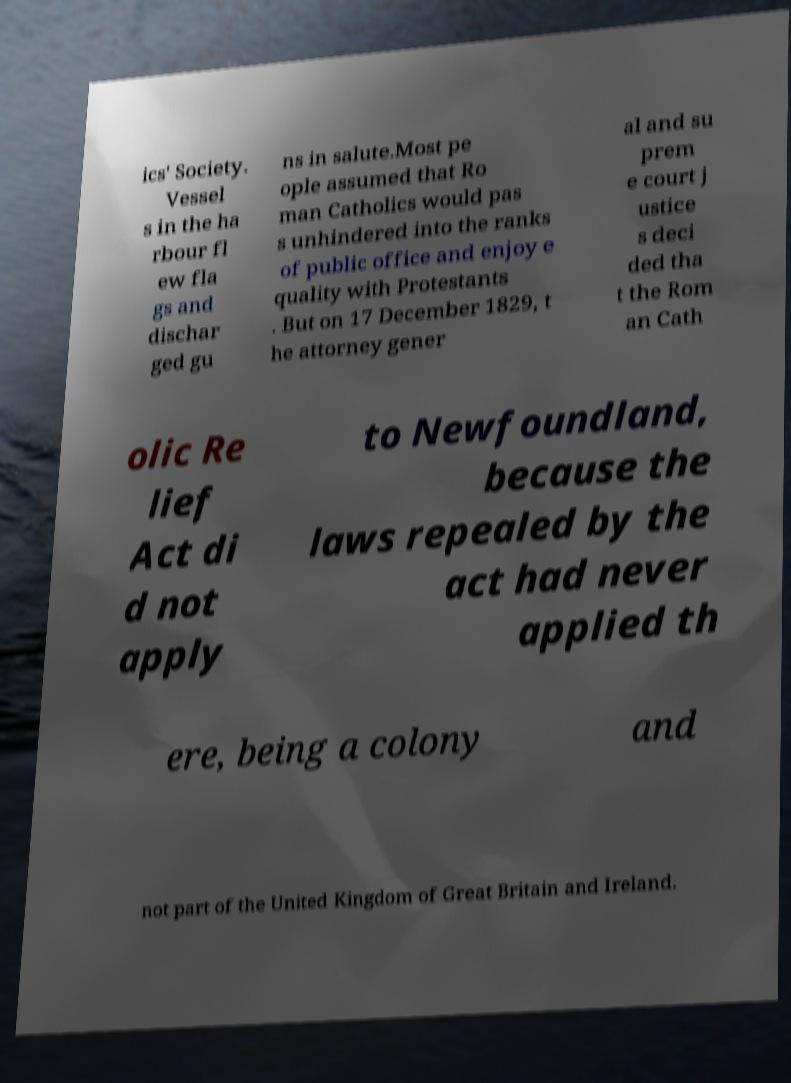Please read and relay the text visible in this image. What does it say? ics' Society. Vessel s in the ha rbour fl ew fla gs and dischar ged gu ns in salute.Most pe ople assumed that Ro man Catholics would pas s unhindered into the ranks of public office and enjoy e quality with Protestants . But on 17 December 1829, t he attorney gener al and su prem e court j ustice s deci ded tha t the Rom an Cath olic Re lief Act di d not apply to Newfoundland, because the laws repealed by the act had never applied th ere, being a colony and not part of the United Kingdom of Great Britain and Ireland. 